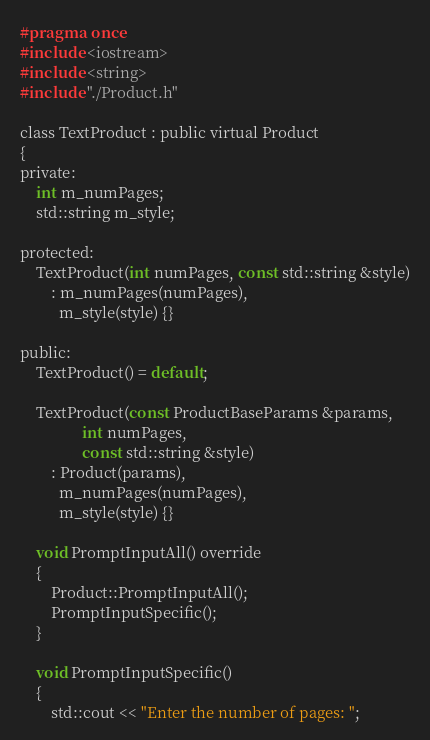Convert code to text. <code><loc_0><loc_0><loc_500><loc_500><_C_>#pragma once
#include <iostream>
#include <string>
#include "./Product.h"

class TextProduct : public virtual Product
{
private:
    int m_numPages;
    std::string m_style;

protected:
    TextProduct(int numPages, const std::string &style)
        : m_numPages(numPages),
          m_style(style) {}

public:
    TextProduct() = default;

    TextProduct(const ProductBaseParams &params,
                int numPages,
                const std::string &style)
        : Product(params),
          m_numPages(numPages),
          m_style(style) {}

    void PromptInputAll() override
    {
        Product::PromptInputAll();
        PromptInputSpecific();
    }

    void PromptInputSpecific()
    {
        std::cout << "Enter the number of pages: ";</code> 